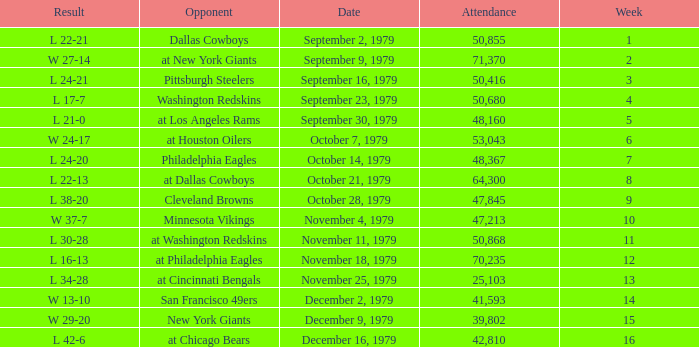What result in a week over 2 occurred with an attendance greater than 53,043 on November 18, 1979? L 16-13. Write the full table. {'header': ['Result', 'Opponent', 'Date', 'Attendance', 'Week'], 'rows': [['L 22-21', 'Dallas Cowboys', 'September 2, 1979', '50,855', '1'], ['W 27-14', 'at New York Giants', 'September 9, 1979', '71,370', '2'], ['L 24-21', 'Pittsburgh Steelers', 'September 16, 1979', '50,416', '3'], ['L 17-7', 'Washington Redskins', 'September 23, 1979', '50,680', '4'], ['L 21-0', 'at Los Angeles Rams', 'September 30, 1979', '48,160', '5'], ['W 24-17', 'at Houston Oilers', 'October 7, 1979', '53,043', '6'], ['L 24-20', 'Philadelphia Eagles', 'October 14, 1979', '48,367', '7'], ['L 22-13', 'at Dallas Cowboys', 'October 21, 1979', '64,300', '8'], ['L 38-20', 'Cleveland Browns', 'October 28, 1979', '47,845', '9'], ['W 37-7', 'Minnesota Vikings', 'November 4, 1979', '47,213', '10'], ['L 30-28', 'at Washington Redskins', 'November 11, 1979', '50,868', '11'], ['L 16-13', 'at Philadelphia Eagles', 'November 18, 1979', '70,235', '12'], ['L 34-28', 'at Cincinnati Bengals', 'November 25, 1979', '25,103', '13'], ['W 13-10', 'San Francisco 49ers', 'December 2, 1979', '41,593', '14'], ['W 29-20', 'New York Giants', 'December 9, 1979', '39,802', '15'], ['L 42-6', 'at Chicago Bears', 'December 16, 1979', '42,810', '16']]} 